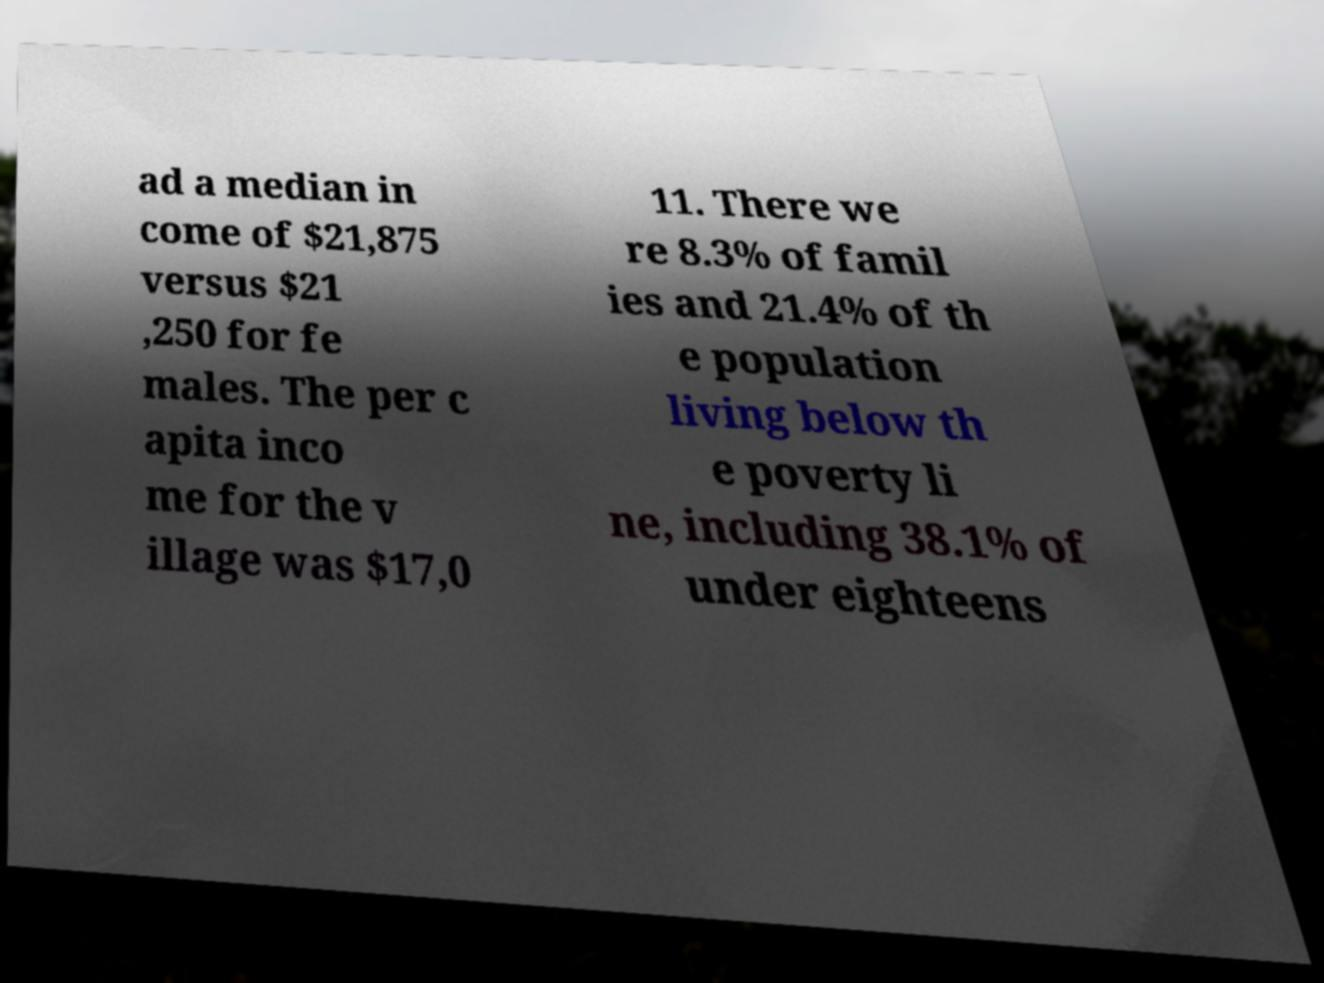Can you read and provide the text displayed in the image?This photo seems to have some interesting text. Can you extract and type it out for me? ad a median in come of $21,875 versus $21 ,250 for fe males. The per c apita inco me for the v illage was $17,0 11. There we re 8.3% of famil ies and 21.4% of th e population living below th e poverty li ne, including 38.1% of under eighteens 